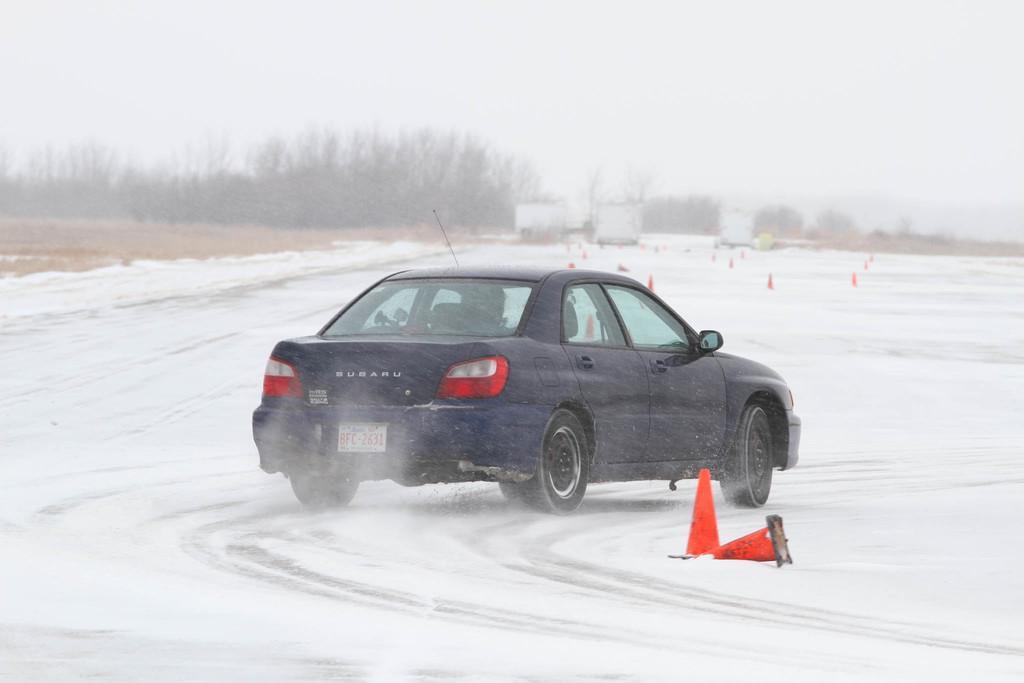Could you give a brief overview of what you see in this image? A car is moving on the snow road, on the left side there are trees, at the top it is the foggy sky. 